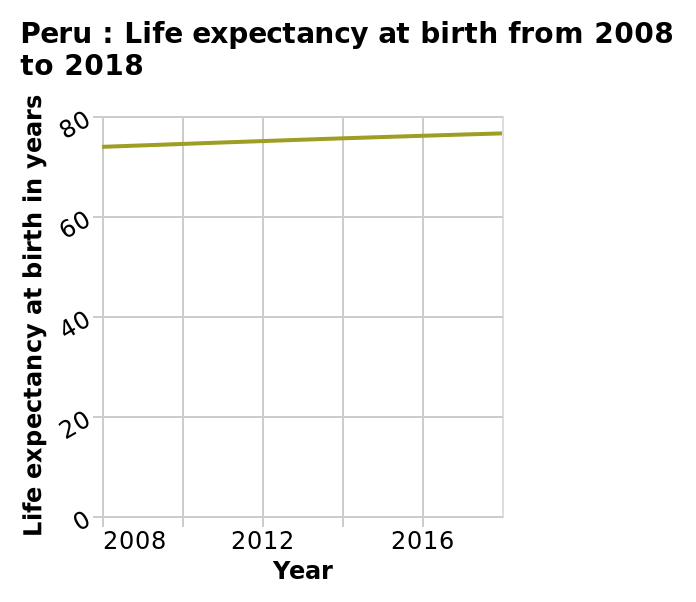<image>
How would you describe the rate of increase in life expectancy at birth over the past decade? The rate of increase in life expectancy at birth over the past decade has been very slow. 